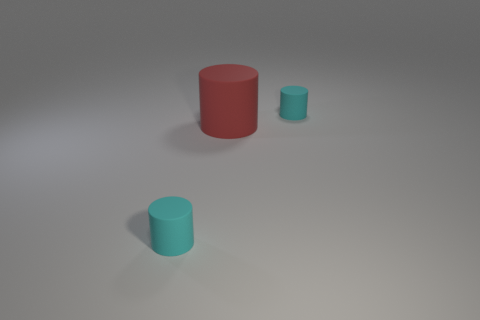Subtract all cyan cylinders. How many cylinders are left? 1 Subtract all cyan cylinders. How many cylinders are left? 1 Add 2 cyan cylinders. How many objects exist? 5 Subtract 3 cylinders. How many cylinders are left? 0 Subtract all purple cylinders. Subtract all blue cubes. How many cylinders are left? 3 Subtract all red blocks. How many blue cylinders are left? 0 Add 3 big blue rubber spheres. How many big blue rubber spheres exist? 3 Subtract 0 green cylinders. How many objects are left? 3 Subtract all tiny cyan matte cylinders. Subtract all red matte objects. How many objects are left? 0 Add 2 rubber cylinders. How many rubber cylinders are left? 5 